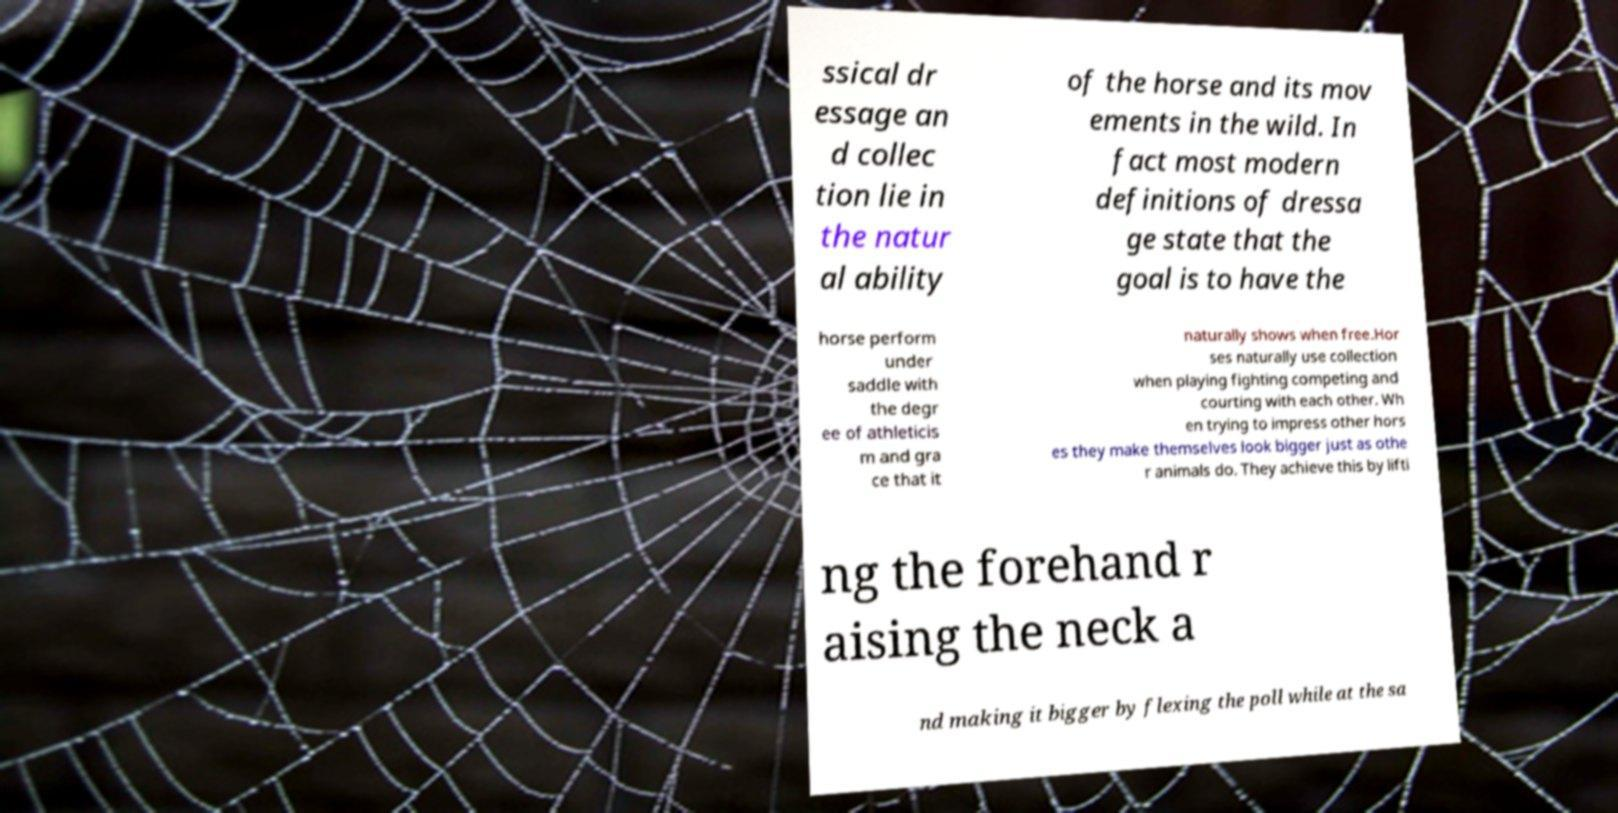What messages or text are displayed in this image? I need them in a readable, typed format. ssical dr essage an d collec tion lie in the natur al ability of the horse and its mov ements in the wild. In fact most modern definitions of dressa ge state that the goal is to have the horse perform under saddle with the degr ee of athleticis m and gra ce that it naturally shows when free.Hor ses naturally use collection when playing fighting competing and courting with each other. Wh en trying to impress other hors es they make themselves look bigger just as othe r animals do. They achieve this by lifti ng the forehand r aising the neck a nd making it bigger by flexing the poll while at the sa 